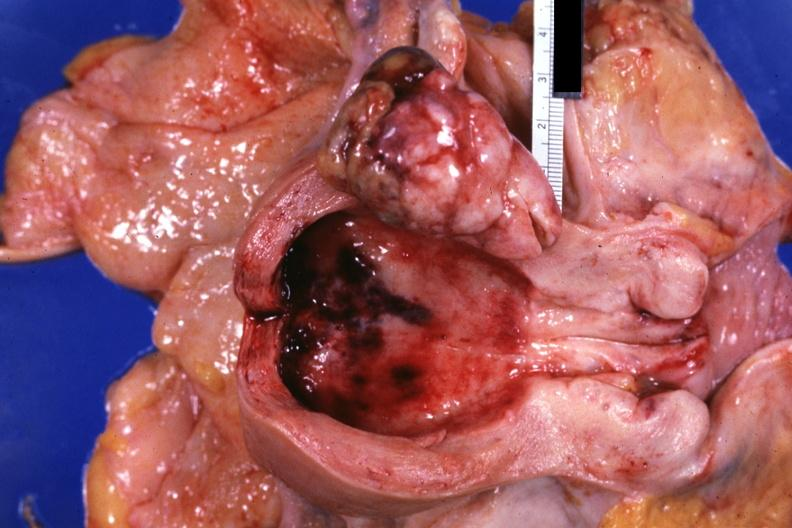where does this part belong to?
Answer the question using a single word or phrase. Female reproductive system 